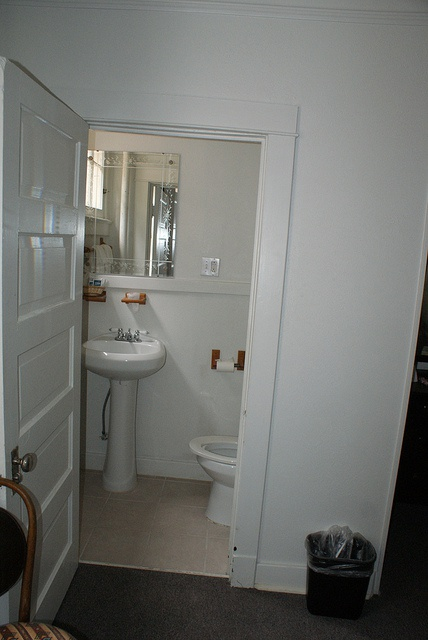Describe the objects in this image and their specific colors. I can see sink in gray, darkgray, and black tones, chair in gray, black, and maroon tones, and toilet in gray tones in this image. 